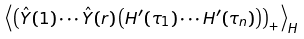<formula> <loc_0><loc_0><loc_500><loc_500>\left \langle \left ( \hat { Y } ( 1 ) \cdots \hat { Y } ( r ) \left ( H ^ { \prime } ( \tau _ { 1 } ) \cdots H ^ { \prime } ( \tau _ { n } ) \right ) \right ) _ { + } \right \rangle _ { H }</formula> 